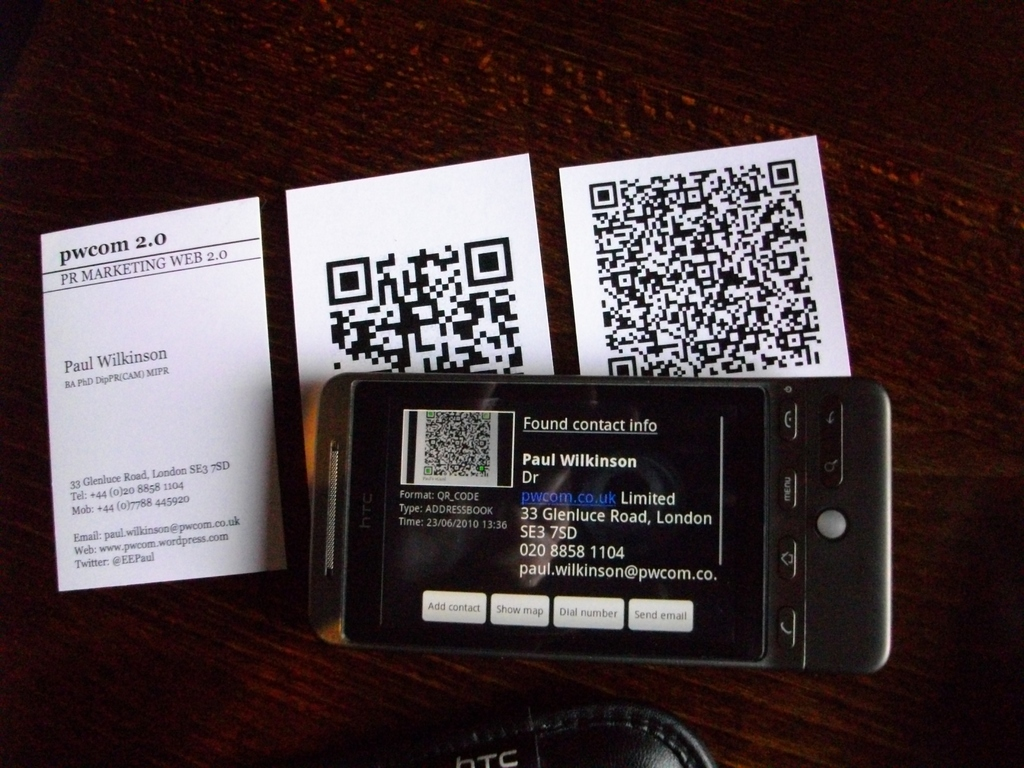How might the elements in this image be used in a professional setting? The elements in the image, such as the business cards and the mobile phone displaying contact details, are typically used for professional networking. They provide a quick and efficient way to exchange contact information during meetings, conferences, or networking events, facilitating professional relationships and communications. Can you suggest a technological advancement that might further improve the utility of these items? A potential technological advancement could be the integration of augmented reality (AR) with business cards and QR codes. By scanning a QR code or business card with an AR-enabled device, detailed multimedia presentations about the individual or company could be displayed, offering a more engaging and informative way to connect with contacts. 